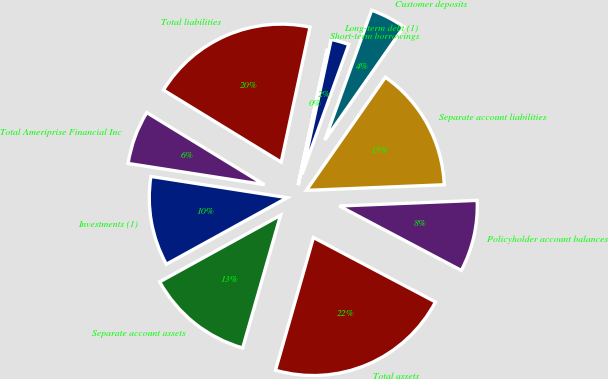<chart> <loc_0><loc_0><loc_500><loc_500><pie_chart><fcel>Investments (1)<fcel>Separate account assets<fcel>Total assets<fcel>Policyholder account balances<fcel>Separate account liabilities<fcel>Customer deposits<fcel>Long-term debt (1)<fcel>Short-term borrowings<fcel>Total liabilities<fcel>Total Ameriprise Financial Inc<nl><fcel>10.47%<fcel>12.56%<fcel>21.7%<fcel>8.38%<fcel>14.65%<fcel>4.2%<fcel>2.12%<fcel>0.03%<fcel>19.61%<fcel>6.29%<nl></chart> 